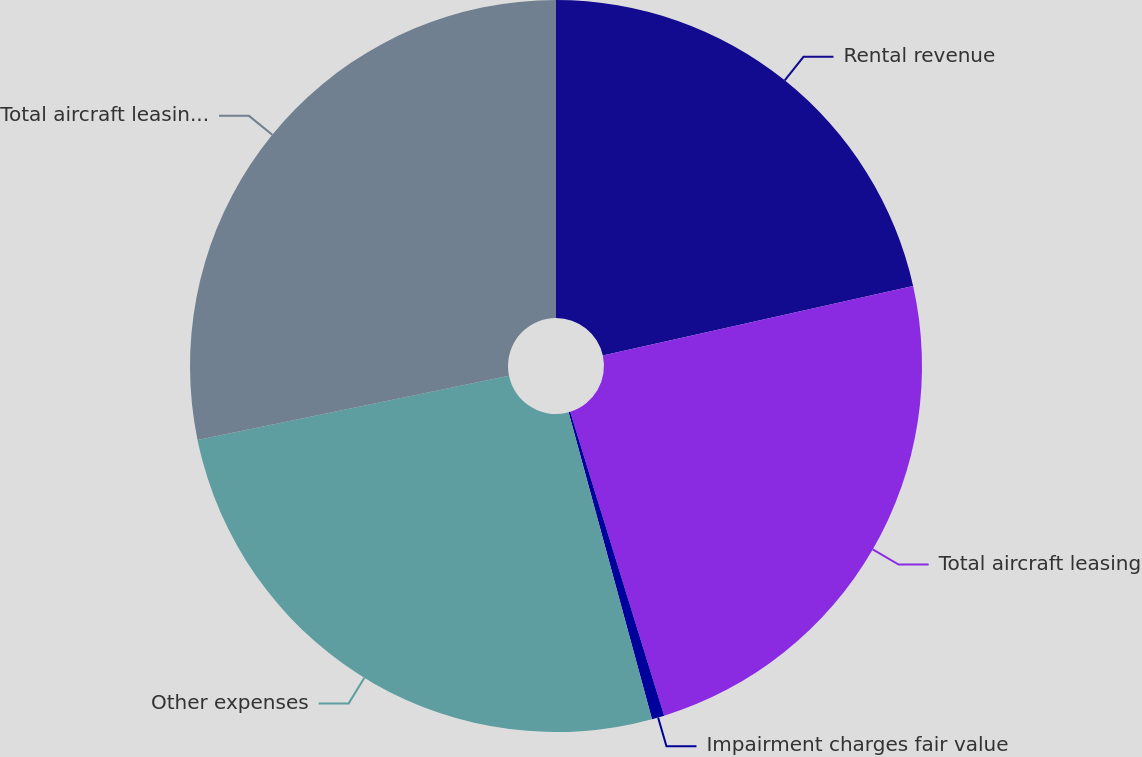Convert chart. <chart><loc_0><loc_0><loc_500><loc_500><pie_chart><fcel>Rental revenue<fcel>Total aircraft leasing<fcel>Impairment charges fair value<fcel>Other expenses<fcel>Total aircraft leasing expense<nl><fcel>21.49%<fcel>23.74%<fcel>0.55%<fcel>25.99%<fcel>28.24%<nl></chart> 